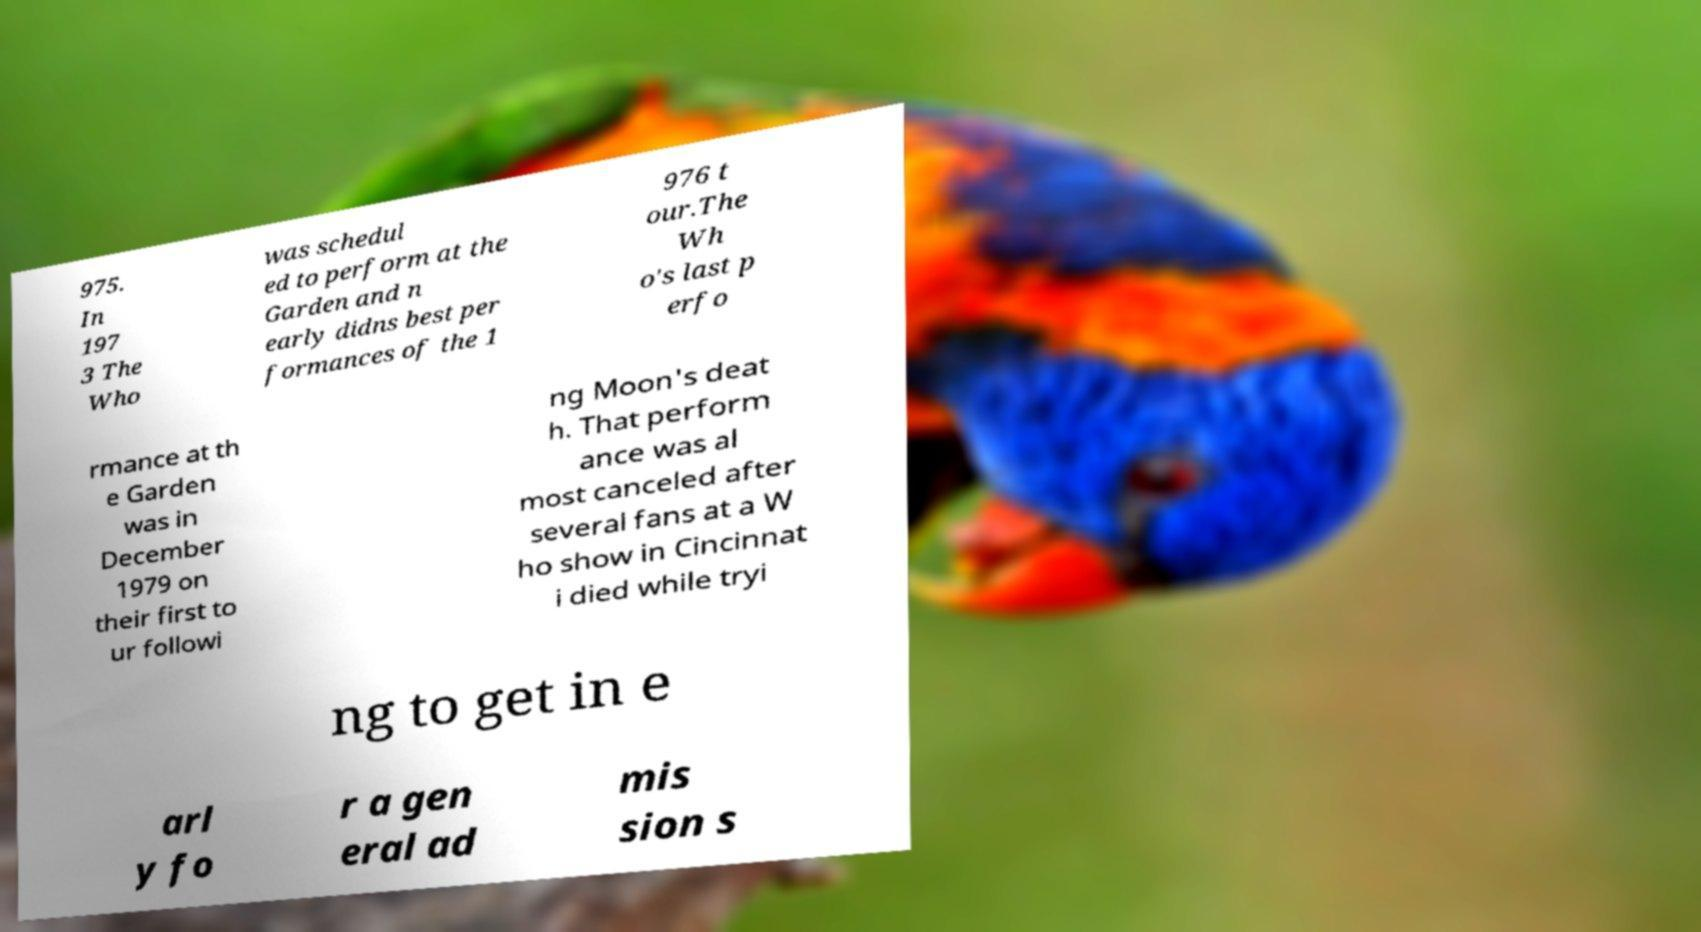Could you extract and type out the text from this image? 975. In 197 3 The Who was schedul ed to perform at the Garden and n early didns best per formances of the 1 976 t our.The Wh o's last p erfo rmance at th e Garden was in December 1979 on their first to ur followi ng Moon's deat h. That perform ance was al most canceled after several fans at a W ho show in Cincinnat i died while tryi ng to get in e arl y fo r a gen eral ad mis sion s 